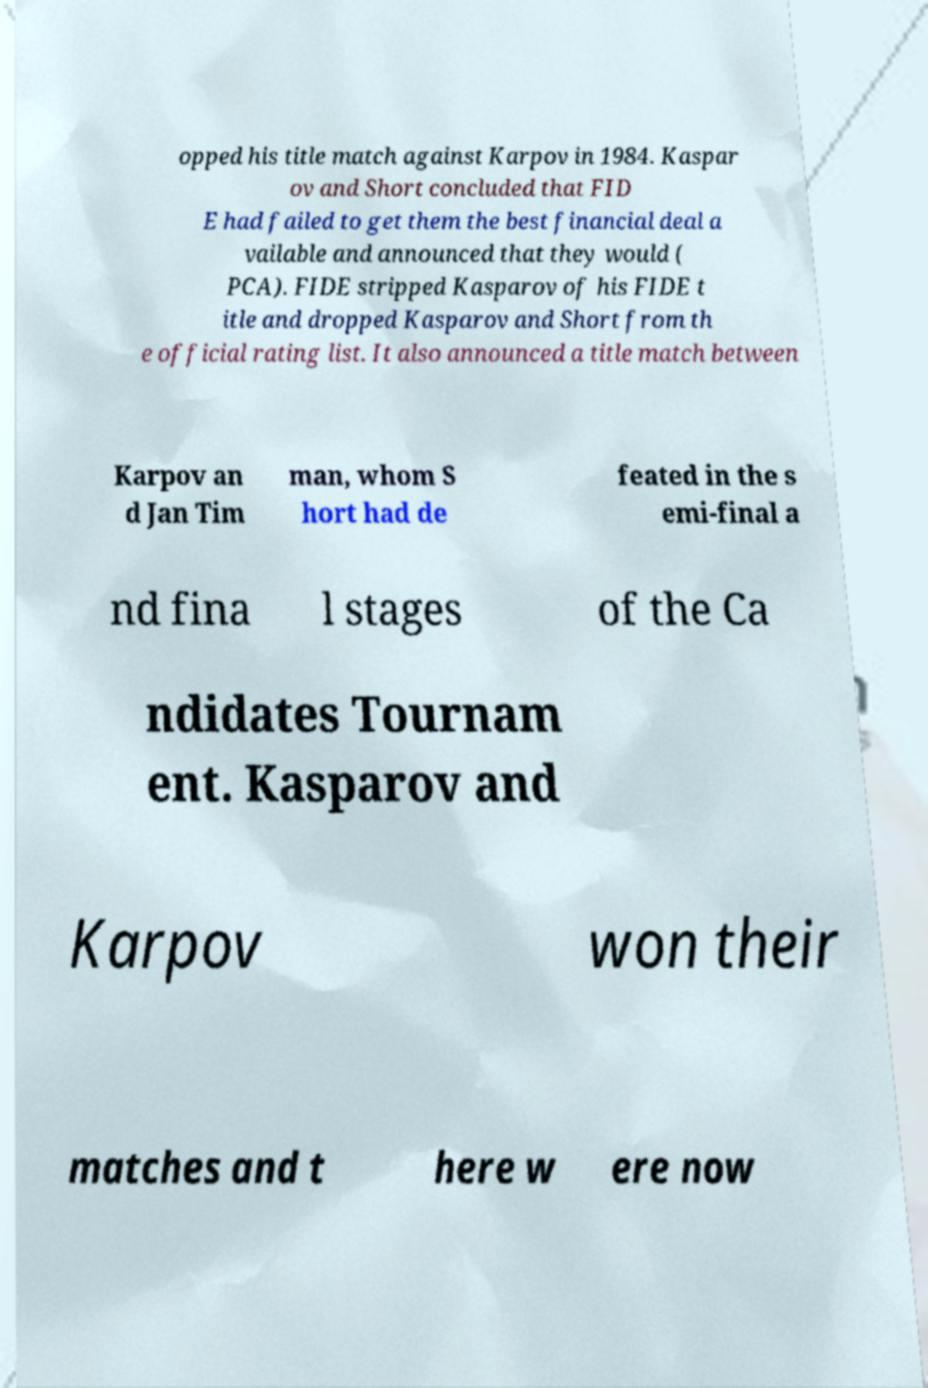I need the written content from this picture converted into text. Can you do that? opped his title match against Karpov in 1984. Kaspar ov and Short concluded that FID E had failed to get them the best financial deal a vailable and announced that they would ( PCA). FIDE stripped Kasparov of his FIDE t itle and dropped Kasparov and Short from th e official rating list. It also announced a title match between Karpov an d Jan Tim man, whom S hort had de feated in the s emi-final a nd fina l stages of the Ca ndidates Tournam ent. Kasparov and Karpov won their matches and t here w ere now 